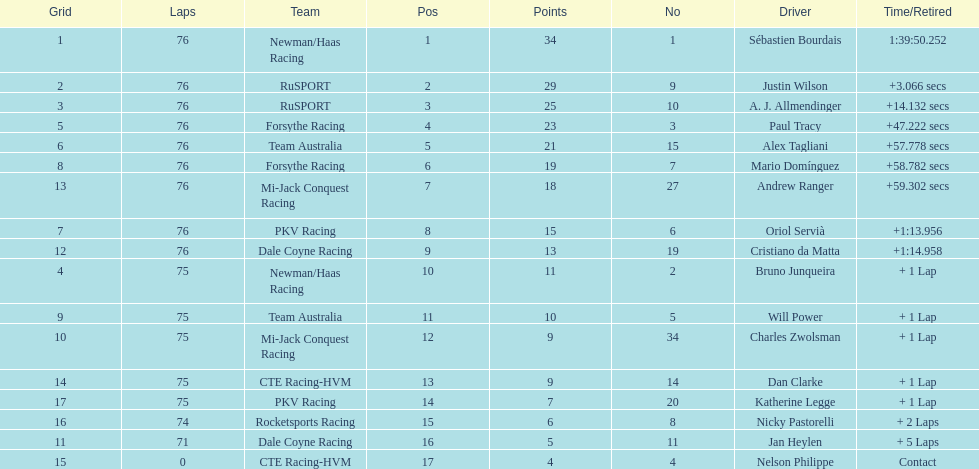How many drivers were competing for brazil? 2. 